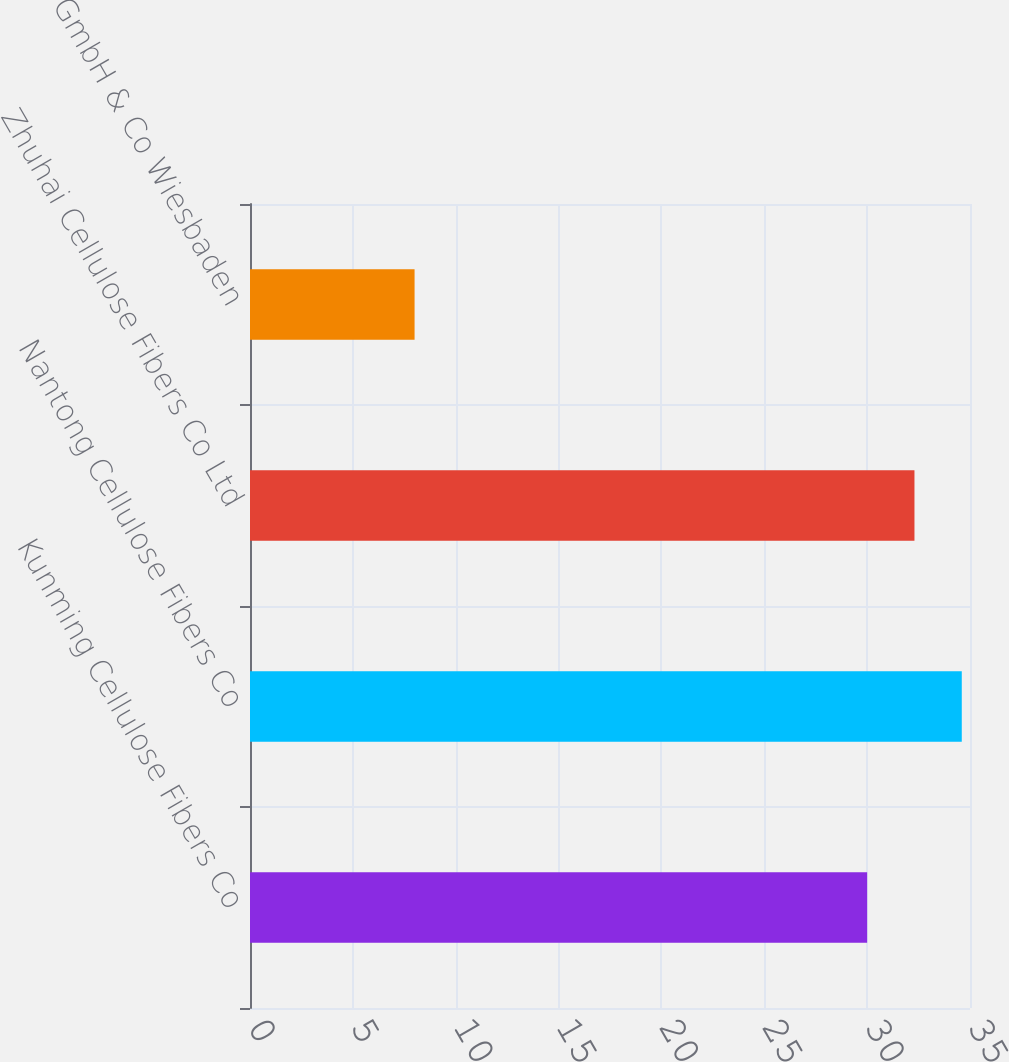Convert chart. <chart><loc_0><loc_0><loc_500><loc_500><bar_chart><fcel>Kunming Cellulose Fibers Co<fcel>Nantong Cellulose Fibers Co<fcel>Zhuhai Cellulose Fibers Co Ltd<fcel>InfraServ GmbH & Co Wiesbaden<nl><fcel>30<fcel>34.6<fcel>32.3<fcel>8<nl></chart> 